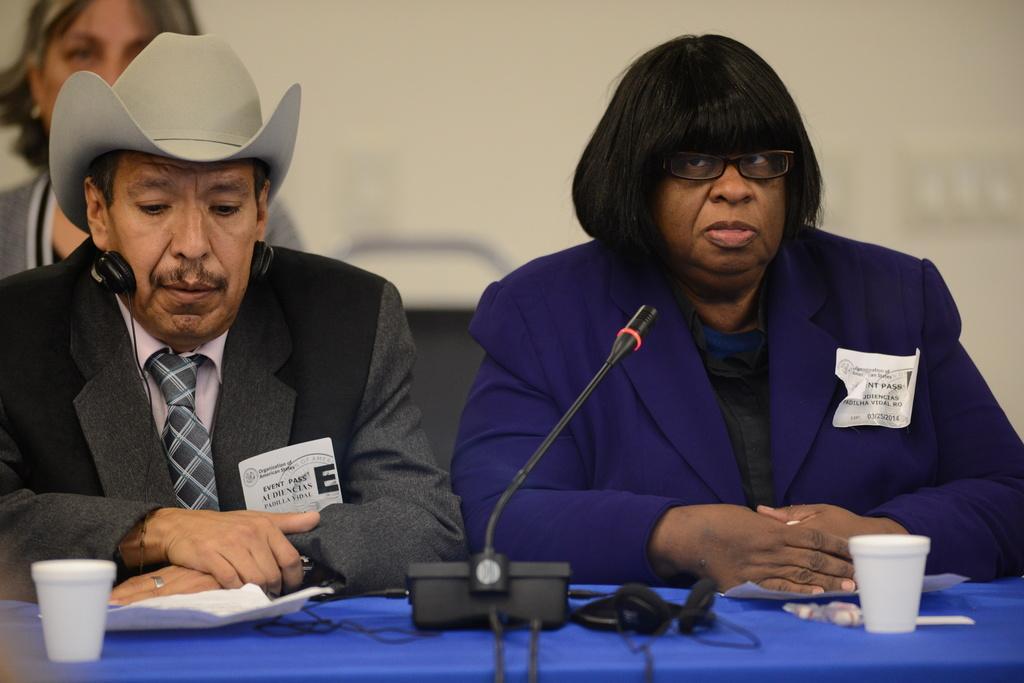In one or two sentences, can you explain what this image depicts? In this image there are persons sitting, the is a truncated towards the right of the image, the persons are truncated towards the left of the image, the persons are truncated towards the top of the image, there is a chair, there is a table truncated towards the bottom of the image, there are objects on the table, at the background of the image there is the wall truncated. 